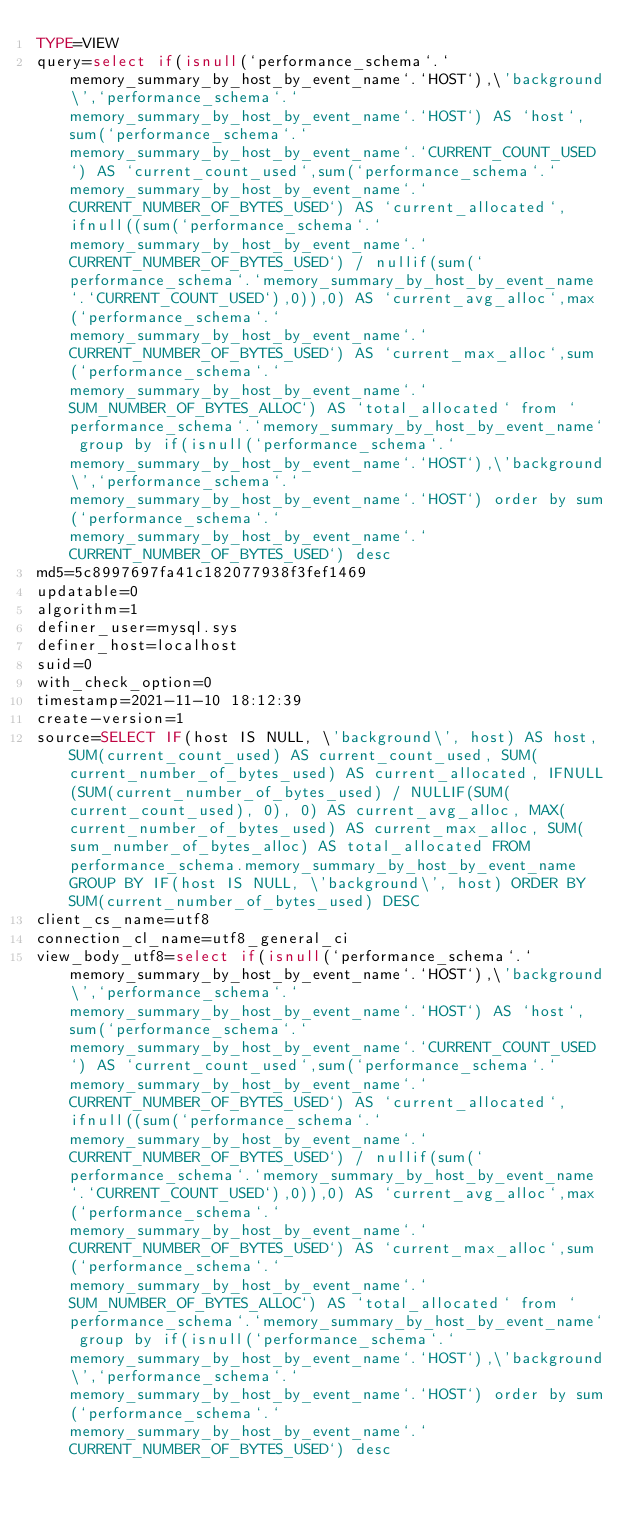<code> <loc_0><loc_0><loc_500><loc_500><_VisualBasic_>TYPE=VIEW
query=select if(isnull(`performance_schema`.`memory_summary_by_host_by_event_name`.`HOST`),\'background\',`performance_schema`.`memory_summary_by_host_by_event_name`.`HOST`) AS `host`,sum(`performance_schema`.`memory_summary_by_host_by_event_name`.`CURRENT_COUNT_USED`) AS `current_count_used`,sum(`performance_schema`.`memory_summary_by_host_by_event_name`.`CURRENT_NUMBER_OF_BYTES_USED`) AS `current_allocated`,ifnull((sum(`performance_schema`.`memory_summary_by_host_by_event_name`.`CURRENT_NUMBER_OF_BYTES_USED`) / nullif(sum(`performance_schema`.`memory_summary_by_host_by_event_name`.`CURRENT_COUNT_USED`),0)),0) AS `current_avg_alloc`,max(`performance_schema`.`memory_summary_by_host_by_event_name`.`CURRENT_NUMBER_OF_BYTES_USED`) AS `current_max_alloc`,sum(`performance_schema`.`memory_summary_by_host_by_event_name`.`SUM_NUMBER_OF_BYTES_ALLOC`) AS `total_allocated` from `performance_schema`.`memory_summary_by_host_by_event_name` group by if(isnull(`performance_schema`.`memory_summary_by_host_by_event_name`.`HOST`),\'background\',`performance_schema`.`memory_summary_by_host_by_event_name`.`HOST`) order by sum(`performance_schema`.`memory_summary_by_host_by_event_name`.`CURRENT_NUMBER_OF_BYTES_USED`) desc
md5=5c8997697fa41c182077938f3fef1469
updatable=0
algorithm=1
definer_user=mysql.sys
definer_host=localhost
suid=0
with_check_option=0
timestamp=2021-11-10 18:12:39
create-version=1
source=SELECT IF(host IS NULL, \'background\', host) AS host, SUM(current_count_used) AS current_count_used, SUM(current_number_of_bytes_used) AS current_allocated, IFNULL(SUM(current_number_of_bytes_used) / NULLIF(SUM(current_count_used), 0), 0) AS current_avg_alloc, MAX(current_number_of_bytes_used) AS current_max_alloc, SUM(sum_number_of_bytes_alloc) AS total_allocated FROM performance_schema.memory_summary_by_host_by_event_name GROUP BY IF(host IS NULL, \'background\', host) ORDER BY SUM(current_number_of_bytes_used) DESC
client_cs_name=utf8
connection_cl_name=utf8_general_ci
view_body_utf8=select if(isnull(`performance_schema`.`memory_summary_by_host_by_event_name`.`HOST`),\'background\',`performance_schema`.`memory_summary_by_host_by_event_name`.`HOST`) AS `host`,sum(`performance_schema`.`memory_summary_by_host_by_event_name`.`CURRENT_COUNT_USED`) AS `current_count_used`,sum(`performance_schema`.`memory_summary_by_host_by_event_name`.`CURRENT_NUMBER_OF_BYTES_USED`) AS `current_allocated`,ifnull((sum(`performance_schema`.`memory_summary_by_host_by_event_name`.`CURRENT_NUMBER_OF_BYTES_USED`) / nullif(sum(`performance_schema`.`memory_summary_by_host_by_event_name`.`CURRENT_COUNT_USED`),0)),0) AS `current_avg_alloc`,max(`performance_schema`.`memory_summary_by_host_by_event_name`.`CURRENT_NUMBER_OF_BYTES_USED`) AS `current_max_alloc`,sum(`performance_schema`.`memory_summary_by_host_by_event_name`.`SUM_NUMBER_OF_BYTES_ALLOC`) AS `total_allocated` from `performance_schema`.`memory_summary_by_host_by_event_name` group by if(isnull(`performance_schema`.`memory_summary_by_host_by_event_name`.`HOST`),\'background\',`performance_schema`.`memory_summary_by_host_by_event_name`.`HOST`) order by sum(`performance_schema`.`memory_summary_by_host_by_event_name`.`CURRENT_NUMBER_OF_BYTES_USED`) desc
</code> 